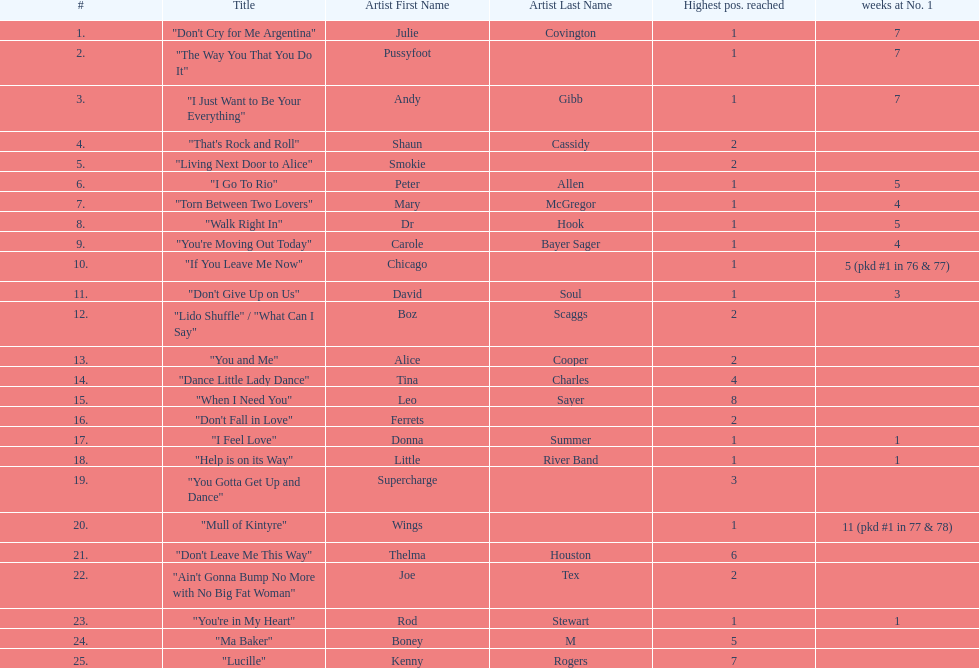How many weeks did julie covington's "don't cry for me argentina" spend at the top of australia's singles chart? 7. 